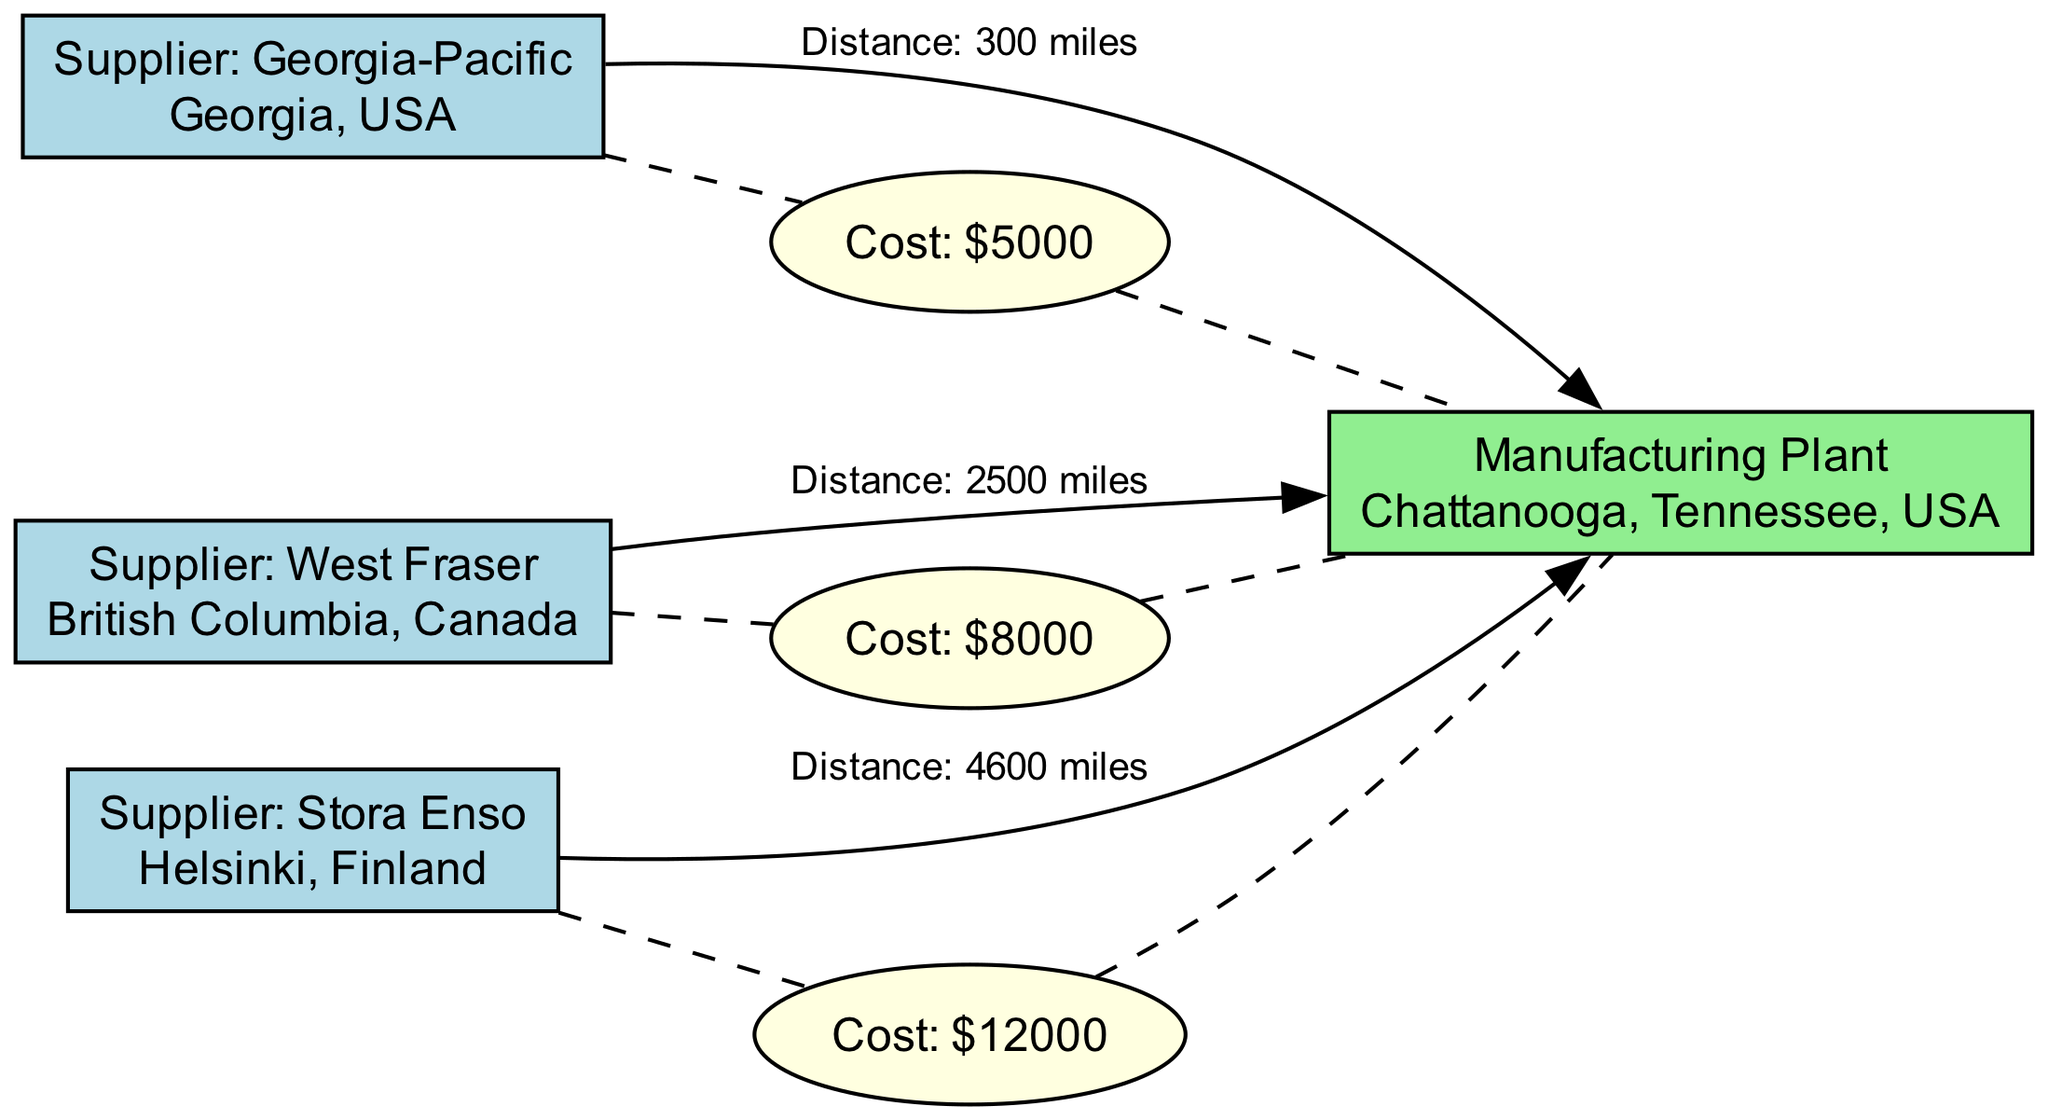What is the maximum transportation cost in the diagram? To find the maximum transportation cost, I look for the transportation costs associated with the suppliers to the manufacturing plant. The costs are $5000, $8000, and $12000, with $12000 being the highest among them.
Answer: $12000 Which supplier is closest to the manufacturing plant? I analyze the distances provided from each supplier to the manufacturing plant: 300 miles for Georgia-Pacific, 2500 miles for West Fraser, and 4600 miles for Stora Enso. The smallest distance is 300 miles from Georgia-Pacific, making it the closest supplier.
Answer: Georgia-Pacific How many suppliers are listed in the diagram? I count the number of supplier nodes present in the diagram, which are Georgia-Pacific, West Fraser, and Stora Enso, totaling three suppliers.
Answer: 3 What is the distance from West Fraser to the manufacturing plant? The distance from West Fraser to the manufacturing plant is given in the edge connecting them, which states the distance is 2500 miles.
Answer: 2500 miles Which supplier has the highest transportation cost? I compare the transportation costs linked to each supplier: $5000 for Georgia-Pacific, $8000 for West Fraser, and $12000 for Stora Enso. Stora Enso's associated cost of $12000 is the highest among all suppliers.
Answer: Stora Enso What type of diagram is this? This diagram represents the supply chain dynamics, specifically focusing on suppliers, a manufacturing plant, and associated transportation costs. This is characteristic of a social science diagram.
Answer: Social Science Diagram How many edges connect the manufacturing plant to suppliers? There are three suppliers, each connected to the manufacturing plant by an edge, so there are three edges connecting the manufacturing plant to suppliers.
Answer: 3 Which supplier's transportation cost is associated with a distance of 4600 miles? The transportation cost associated with a distance of 4600 miles is linked to Stora Enso, as that is the distance stated for its connection to the manufacturing plant.
Answer: Stora Enso 